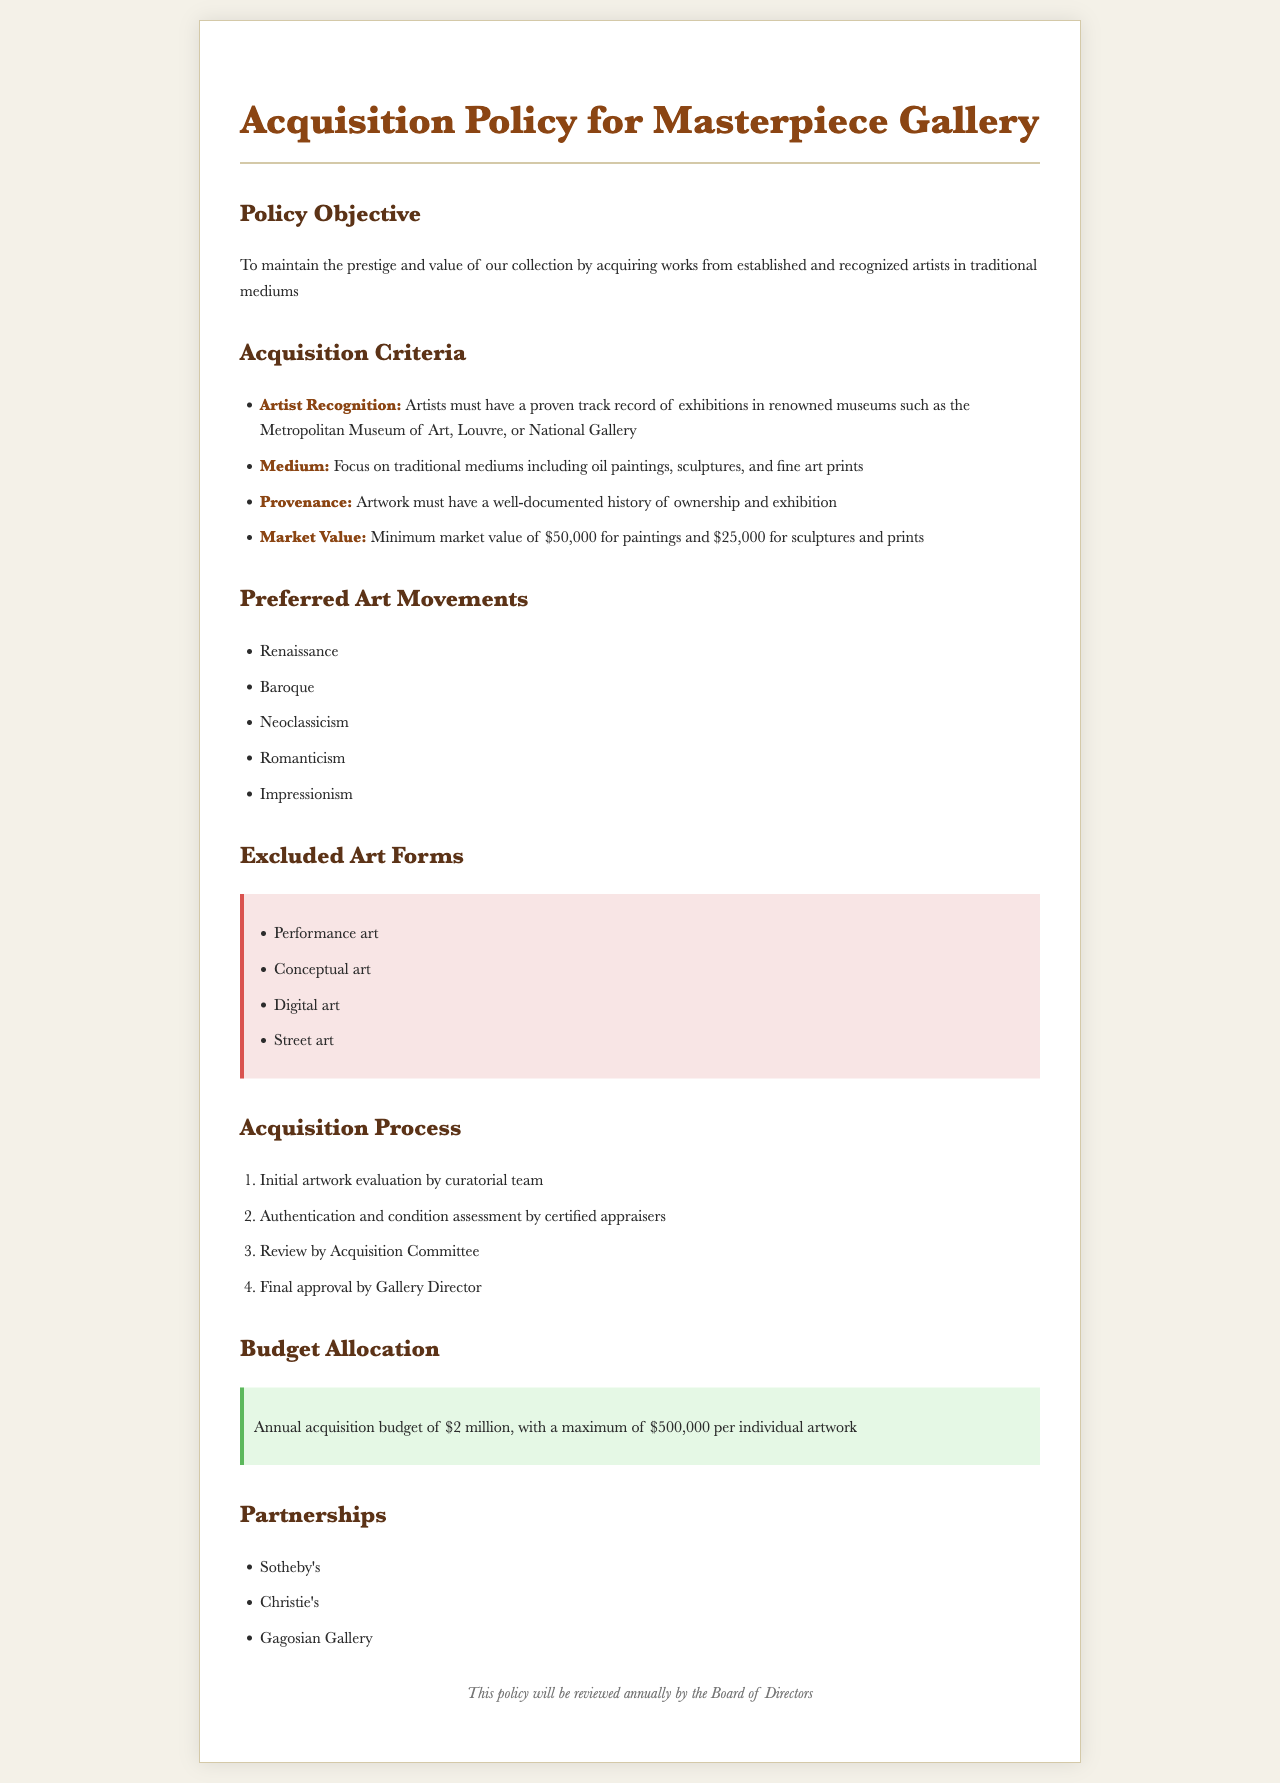What is the policy objective? The policy objective is stated as maintaining the prestige and value of the collection, which involves acquiring works from established and recognized artists in traditional mediums.
Answer: To maintain the prestige and value of our collection by acquiring works from established and recognized artists in traditional mediums What is the minimum market value for paintings? The document specifies the minimum market value required for paintings, which is stated clearly in the Acquisition Criteria section.
Answer: $50,000 Which art forms are excluded from acquisition? The excluded art forms are listed in a dedicated section, providing a clear understanding of what is not accepted.
Answer: Performance art, Conceptual art, Digital art, Street art What is the annual acquisition budget? The document mentions the total budget allocated for acquisitions, highlighting the financial aspects related to purchasing artworks.
Answer: $2 million Who conducts the initial artwork evaluation? The acquisition process describes the parties involved in the evaluation, specifying who is responsible for the initial assessment.
Answer: Curatorial team How many preferred art movements are listed? The document outlines specific art movements, indicating the number of such movements considered within the acquisition policy.
Answer: Five 